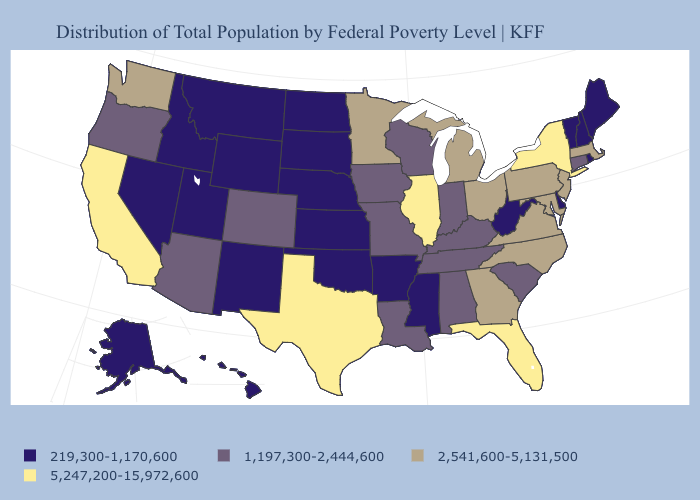What is the highest value in the Northeast ?
Keep it brief. 5,247,200-15,972,600. Does the map have missing data?
Write a very short answer. No. What is the highest value in states that border Massachusetts?
Answer briefly. 5,247,200-15,972,600. How many symbols are there in the legend?
Keep it brief. 4. Name the states that have a value in the range 1,197,300-2,444,600?
Short answer required. Alabama, Arizona, Colorado, Connecticut, Indiana, Iowa, Kentucky, Louisiana, Missouri, Oregon, South Carolina, Tennessee, Wisconsin. Name the states that have a value in the range 2,541,600-5,131,500?
Keep it brief. Georgia, Maryland, Massachusetts, Michigan, Minnesota, New Jersey, North Carolina, Ohio, Pennsylvania, Virginia, Washington. Is the legend a continuous bar?
Answer briefly. No. How many symbols are there in the legend?
Concise answer only. 4. What is the value of Colorado?
Write a very short answer. 1,197,300-2,444,600. Name the states that have a value in the range 1,197,300-2,444,600?
Short answer required. Alabama, Arizona, Colorado, Connecticut, Indiana, Iowa, Kentucky, Louisiana, Missouri, Oregon, South Carolina, Tennessee, Wisconsin. Among the states that border Oregon , which have the lowest value?
Keep it brief. Idaho, Nevada. Among the states that border New Jersey , which have the lowest value?
Write a very short answer. Delaware. What is the highest value in the USA?
Keep it brief. 5,247,200-15,972,600. 